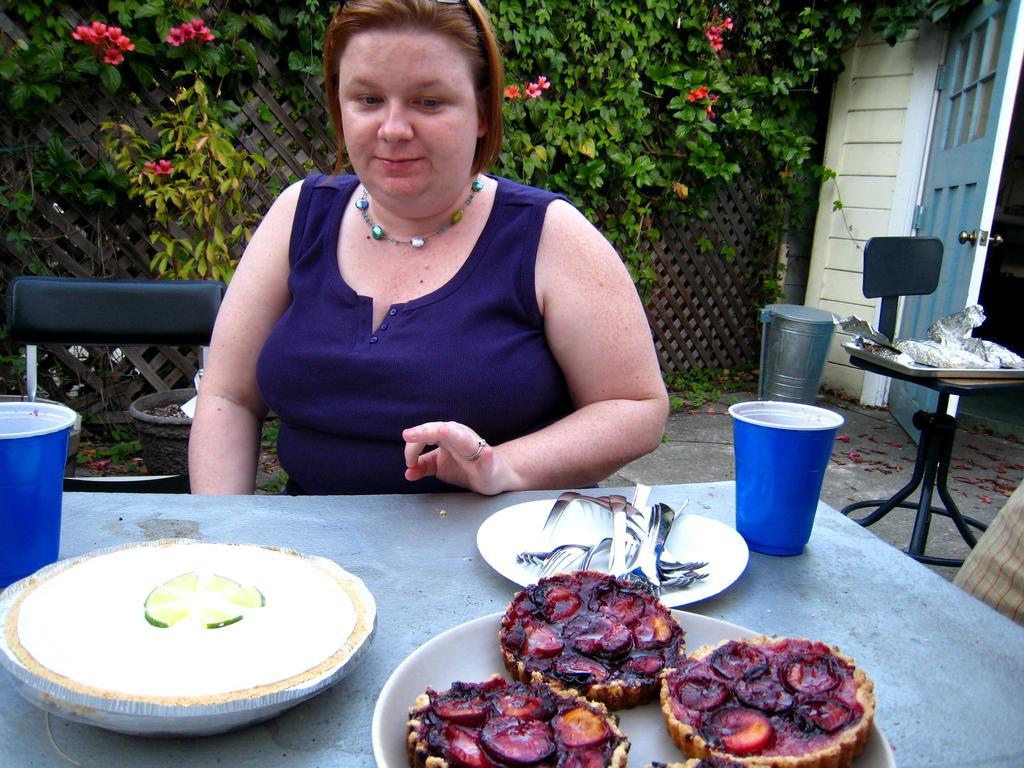Please provide a concise description of this image. In this picture we can see a woman is sitting. In front of the woman there is a table and on the table there are plates, forks, cups and some food items. On the right side of the woman there is a dustbin and another table and on the table there is a tray with some objects. On the left side of the woman there is a chair. Behind the woman there is a plant in the pot. Behind the plant, it looks like the fence and plants. 